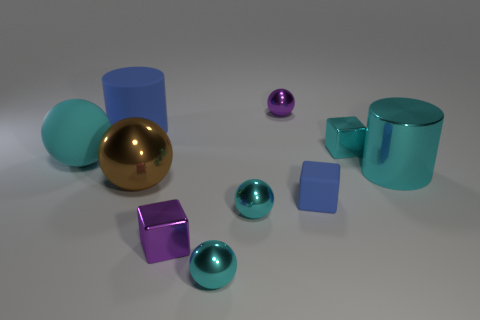What is the color of the matte cylinder that is the same size as the brown sphere?
Give a very brief answer. Blue. There is a large cyan metallic object; does it have the same shape as the blue matte thing that is behind the large cyan metal thing?
Your answer should be very brief. Yes. The large thing that is the same color as the metallic cylinder is what shape?
Offer a very short reply. Sphere. There is a blue rubber thing on the left side of the tiny purple thing in front of the blue block; how many big spheres are on the left side of it?
Offer a very short reply. 1. There is a purple object that is in front of the purple object that is behind the brown metallic thing; what size is it?
Your response must be concise. Small. There is a cyan thing that is the same material as the blue block; what is its size?
Provide a short and direct response. Large. What shape is the big object that is on the left side of the small purple ball and right of the blue rubber cylinder?
Keep it short and to the point. Sphere. Are there the same number of tiny cyan spheres that are behind the purple shiny block and blue objects?
Provide a short and direct response. No. What number of things are brown balls or things behind the blue rubber cylinder?
Keep it short and to the point. 2. Are there any large cyan rubber things that have the same shape as the tiny blue rubber thing?
Your answer should be compact. No. 